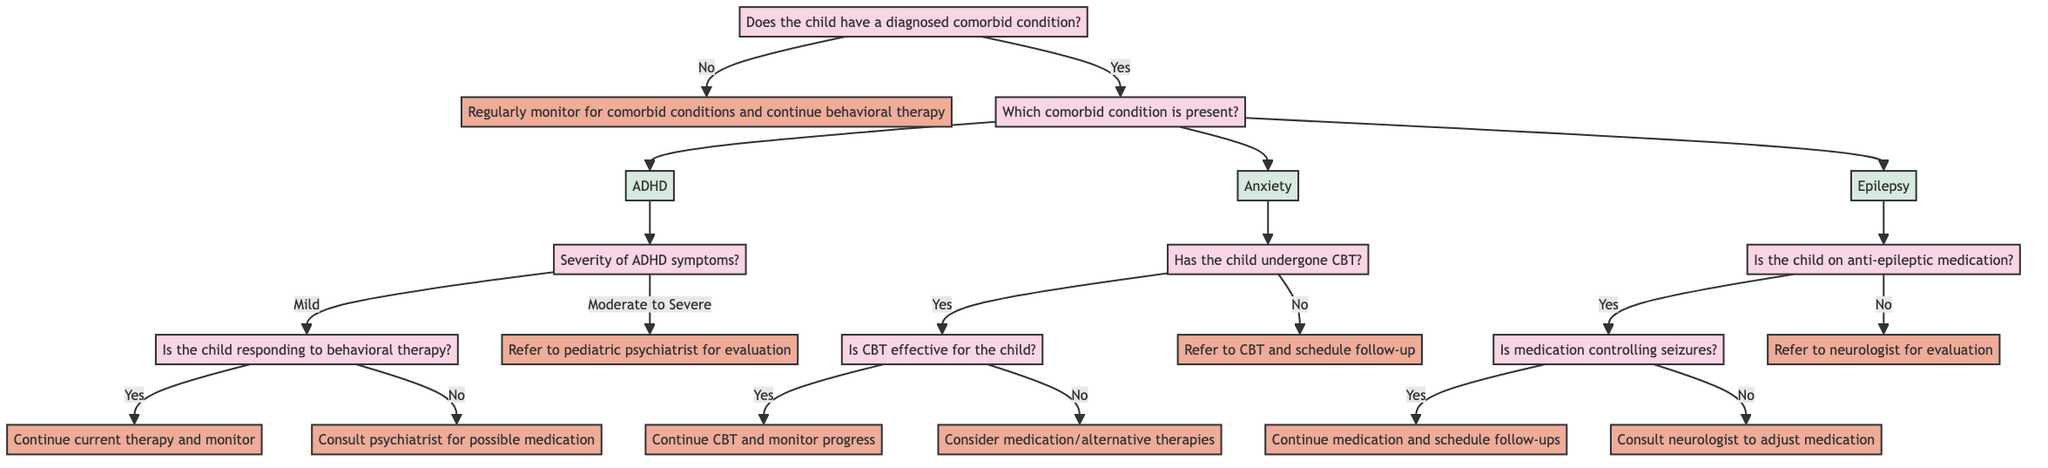Does the child have a diagnosed comorbid condition? The starting question in the decision tree asks whether a diagnosed comorbid condition exists. This leads to two paths: if the answer is yes, the tree continues to categorize the condition; if no, the action is to monitor and continue therapy.
Answer: Yes or No What are the three comorbid conditions listed? The diagram provides three specific comorbid conditions: ADHD, Anxiety, and Epilepsy. These conditions branch out from the question about whether any comorbid condition is present.
Answer: ADHD, Anxiety, Epilepsy What happens if the child has moderate to severe ADHD symptoms? According to the decision tree, if a child has moderate to severe ADHD symptoms, the directed action is to refer them to a pediatric psychiatrist for evaluation and possible medication.
Answer: Refer to a pediatric psychiatrist for evaluation If the child is on anti-epileptic medication and it is controlling seizures, what is the next step? In this scenario, if the child is currently taking anti-epileptic medication and it is effectively controlling seizures, the next action is to continue the current medication along with behavioral therapy and schedule regular neurology follow-ups.
Answer: Continue current medication and behavioral therapy What should be done if a child has not undergone cognitive behavioral therapy for Anxiety? If a child has not undergone CBT for Anxiety, the next action according to the diagram is to refer the child to CBT and schedule a follow-up to assess its effectiveness.
Answer: Refer to CBT and schedule follow-up If the child is responding to behavioral therapy for ADHD, what is recommended? If the child demonstrates a positive response to behavioral therapy for ADHD, the diagram recommends continuing the current behavioral therapy while monitoring the child's progress.
Answer: Continue current behavioral therapy and monitor progress What action is recommended if CBT is not effective for the child with Anxiety? When CBT is found to be ineffective, the recommended action is to consider medication and/or alternative therapies while also consulting with a child psychologist as indicated in the tree.
Answer: Consider medication and/or alternative therapies How many total actions can be taken from the root question? By analyzing the possible paths from the root question, we can determine there are four primary actions that can be taken: two actions if no comorbid conditions are present, and two actions for each of the three specific comorbid conditions if they are present, totaling seven unique actions.
Answer: Seven actions What is the question about the severity of ADHD symptoms? The decision tree provides a specific inquiry regarding ADHD symptoms' severity, which is clearly titled "What is the severity of ADHD symptoms?" and splits responses into defined categories.
Answer: What is the severity of ADHD symptoms? 